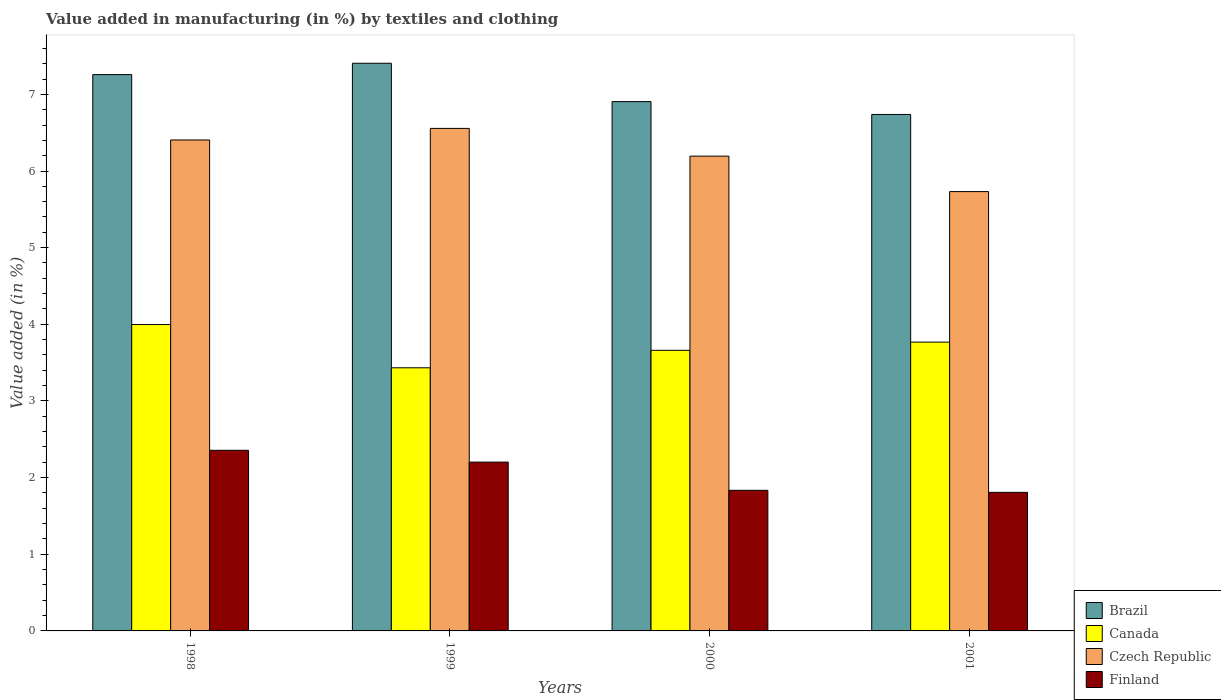How many different coloured bars are there?
Offer a very short reply. 4. How many groups of bars are there?
Your response must be concise. 4. How many bars are there on the 2nd tick from the left?
Offer a terse response. 4. How many bars are there on the 3rd tick from the right?
Offer a terse response. 4. What is the label of the 1st group of bars from the left?
Provide a succinct answer. 1998. What is the percentage of value added in manufacturing by textiles and clothing in Canada in 2000?
Your answer should be very brief. 3.66. Across all years, what is the maximum percentage of value added in manufacturing by textiles and clothing in Finland?
Ensure brevity in your answer.  2.36. Across all years, what is the minimum percentage of value added in manufacturing by textiles and clothing in Brazil?
Your answer should be compact. 6.74. In which year was the percentage of value added in manufacturing by textiles and clothing in Czech Republic maximum?
Keep it short and to the point. 1999. What is the total percentage of value added in manufacturing by textiles and clothing in Canada in the graph?
Make the answer very short. 14.86. What is the difference between the percentage of value added in manufacturing by textiles and clothing in Czech Republic in 1998 and that in 1999?
Give a very brief answer. -0.15. What is the difference between the percentage of value added in manufacturing by textiles and clothing in Czech Republic in 1998 and the percentage of value added in manufacturing by textiles and clothing in Brazil in 2001?
Offer a terse response. -0.33. What is the average percentage of value added in manufacturing by textiles and clothing in Finland per year?
Your answer should be very brief. 2.05. In the year 2001, what is the difference between the percentage of value added in manufacturing by textiles and clothing in Canada and percentage of value added in manufacturing by textiles and clothing in Czech Republic?
Your response must be concise. -1.96. In how many years, is the percentage of value added in manufacturing by textiles and clothing in Finland greater than 0.2 %?
Your answer should be very brief. 4. What is the ratio of the percentage of value added in manufacturing by textiles and clothing in Canada in 1998 to that in 2001?
Make the answer very short. 1.06. What is the difference between the highest and the second highest percentage of value added in manufacturing by textiles and clothing in Canada?
Provide a succinct answer. 0.23. What is the difference between the highest and the lowest percentage of value added in manufacturing by textiles and clothing in Czech Republic?
Provide a succinct answer. 0.82. Is it the case that in every year, the sum of the percentage of value added in manufacturing by textiles and clothing in Canada and percentage of value added in manufacturing by textiles and clothing in Finland is greater than the sum of percentage of value added in manufacturing by textiles and clothing in Brazil and percentage of value added in manufacturing by textiles and clothing in Czech Republic?
Your answer should be very brief. No. What does the 1st bar from the left in 2001 represents?
Offer a very short reply. Brazil. Is it the case that in every year, the sum of the percentage of value added in manufacturing by textiles and clothing in Finland and percentage of value added in manufacturing by textiles and clothing in Canada is greater than the percentage of value added in manufacturing by textiles and clothing in Czech Republic?
Offer a very short reply. No. How many bars are there?
Make the answer very short. 16. Are the values on the major ticks of Y-axis written in scientific E-notation?
Give a very brief answer. No. Does the graph contain any zero values?
Make the answer very short. No. Where does the legend appear in the graph?
Your answer should be compact. Bottom right. How many legend labels are there?
Ensure brevity in your answer.  4. What is the title of the graph?
Provide a short and direct response. Value added in manufacturing (in %) by textiles and clothing. What is the label or title of the Y-axis?
Provide a short and direct response. Value added (in %). What is the Value added (in %) in Brazil in 1998?
Give a very brief answer. 7.26. What is the Value added (in %) in Canada in 1998?
Provide a succinct answer. 4. What is the Value added (in %) of Czech Republic in 1998?
Offer a terse response. 6.4. What is the Value added (in %) in Finland in 1998?
Make the answer very short. 2.36. What is the Value added (in %) in Brazil in 1999?
Offer a very short reply. 7.41. What is the Value added (in %) in Canada in 1999?
Provide a short and direct response. 3.43. What is the Value added (in %) in Czech Republic in 1999?
Your answer should be very brief. 6.56. What is the Value added (in %) of Finland in 1999?
Give a very brief answer. 2.2. What is the Value added (in %) of Brazil in 2000?
Give a very brief answer. 6.91. What is the Value added (in %) of Canada in 2000?
Your response must be concise. 3.66. What is the Value added (in %) of Czech Republic in 2000?
Your response must be concise. 6.19. What is the Value added (in %) in Finland in 2000?
Offer a terse response. 1.83. What is the Value added (in %) in Brazil in 2001?
Your response must be concise. 6.74. What is the Value added (in %) in Canada in 2001?
Provide a short and direct response. 3.77. What is the Value added (in %) in Czech Republic in 2001?
Make the answer very short. 5.73. What is the Value added (in %) in Finland in 2001?
Keep it short and to the point. 1.81. Across all years, what is the maximum Value added (in %) in Brazil?
Your answer should be compact. 7.41. Across all years, what is the maximum Value added (in %) in Canada?
Your response must be concise. 4. Across all years, what is the maximum Value added (in %) of Czech Republic?
Your answer should be compact. 6.56. Across all years, what is the maximum Value added (in %) in Finland?
Give a very brief answer. 2.36. Across all years, what is the minimum Value added (in %) of Brazil?
Your response must be concise. 6.74. Across all years, what is the minimum Value added (in %) in Canada?
Ensure brevity in your answer.  3.43. Across all years, what is the minimum Value added (in %) in Czech Republic?
Provide a short and direct response. 5.73. Across all years, what is the minimum Value added (in %) in Finland?
Keep it short and to the point. 1.81. What is the total Value added (in %) in Brazil in the graph?
Your answer should be very brief. 28.31. What is the total Value added (in %) of Canada in the graph?
Your answer should be compact. 14.86. What is the total Value added (in %) in Czech Republic in the graph?
Keep it short and to the point. 24.89. What is the total Value added (in %) in Finland in the graph?
Your response must be concise. 8.2. What is the difference between the Value added (in %) in Brazil in 1998 and that in 1999?
Ensure brevity in your answer.  -0.15. What is the difference between the Value added (in %) of Canada in 1998 and that in 1999?
Your response must be concise. 0.56. What is the difference between the Value added (in %) of Czech Republic in 1998 and that in 1999?
Make the answer very short. -0.15. What is the difference between the Value added (in %) in Finland in 1998 and that in 1999?
Keep it short and to the point. 0.15. What is the difference between the Value added (in %) of Brazil in 1998 and that in 2000?
Offer a terse response. 0.35. What is the difference between the Value added (in %) in Canada in 1998 and that in 2000?
Your response must be concise. 0.34. What is the difference between the Value added (in %) in Czech Republic in 1998 and that in 2000?
Offer a very short reply. 0.21. What is the difference between the Value added (in %) in Finland in 1998 and that in 2000?
Provide a short and direct response. 0.52. What is the difference between the Value added (in %) in Brazil in 1998 and that in 2001?
Ensure brevity in your answer.  0.52. What is the difference between the Value added (in %) in Canada in 1998 and that in 2001?
Keep it short and to the point. 0.23. What is the difference between the Value added (in %) in Czech Republic in 1998 and that in 2001?
Provide a succinct answer. 0.67. What is the difference between the Value added (in %) of Finland in 1998 and that in 2001?
Offer a very short reply. 0.55. What is the difference between the Value added (in %) in Brazil in 1999 and that in 2000?
Offer a very short reply. 0.5. What is the difference between the Value added (in %) in Canada in 1999 and that in 2000?
Your answer should be compact. -0.23. What is the difference between the Value added (in %) in Czech Republic in 1999 and that in 2000?
Your response must be concise. 0.36. What is the difference between the Value added (in %) of Finland in 1999 and that in 2000?
Your answer should be very brief. 0.37. What is the difference between the Value added (in %) in Brazil in 1999 and that in 2001?
Your response must be concise. 0.67. What is the difference between the Value added (in %) in Canada in 1999 and that in 2001?
Offer a terse response. -0.34. What is the difference between the Value added (in %) of Czech Republic in 1999 and that in 2001?
Offer a terse response. 0.82. What is the difference between the Value added (in %) of Finland in 1999 and that in 2001?
Offer a terse response. 0.39. What is the difference between the Value added (in %) in Brazil in 2000 and that in 2001?
Make the answer very short. 0.17. What is the difference between the Value added (in %) of Canada in 2000 and that in 2001?
Keep it short and to the point. -0.11. What is the difference between the Value added (in %) in Czech Republic in 2000 and that in 2001?
Offer a terse response. 0.46. What is the difference between the Value added (in %) in Finland in 2000 and that in 2001?
Your answer should be very brief. 0.03. What is the difference between the Value added (in %) in Brazil in 1998 and the Value added (in %) in Canada in 1999?
Give a very brief answer. 3.82. What is the difference between the Value added (in %) of Brazil in 1998 and the Value added (in %) of Czech Republic in 1999?
Keep it short and to the point. 0.7. What is the difference between the Value added (in %) in Brazil in 1998 and the Value added (in %) in Finland in 1999?
Your response must be concise. 5.06. What is the difference between the Value added (in %) of Canada in 1998 and the Value added (in %) of Czech Republic in 1999?
Provide a short and direct response. -2.56. What is the difference between the Value added (in %) in Canada in 1998 and the Value added (in %) in Finland in 1999?
Offer a terse response. 1.79. What is the difference between the Value added (in %) of Czech Republic in 1998 and the Value added (in %) of Finland in 1999?
Provide a short and direct response. 4.2. What is the difference between the Value added (in %) of Brazil in 1998 and the Value added (in %) of Canada in 2000?
Give a very brief answer. 3.6. What is the difference between the Value added (in %) in Brazil in 1998 and the Value added (in %) in Czech Republic in 2000?
Give a very brief answer. 1.06. What is the difference between the Value added (in %) of Brazil in 1998 and the Value added (in %) of Finland in 2000?
Keep it short and to the point. 5.42. What is the difference between the Value added (in %) of Canada in 1998 and the Value added (in %) of Czech Republic in 2000?
Offer a very short reply. -2.2. What is the difference between the Value added (in %) in Canada in 1998 and the Value added (in %) in Finland in 2000?
Your answer should be compact. 2.16. What is the difference between the Value added (in %) of Czech Republic in 1998 and the Value added (in %) of Finland in 2000?
Make the answer very short. 4.57. What is the difference between the Value added (in %) of Brazil in 1998 and the Value added (in %) of Canada in 2001?
Provide a short and direct response. 3.49. What is the difference between the Value added (in %) of Brazil in 1998 and the Value added (in %) of Czech Republic in 2001?
Ensure brevity in your answer.  1.53. What is the difference between the Value added (in %) in Brazil in 1998 and the Value added (in %) in Finland in 2001?
Your answer should be very brief. 5.45. What is the difference between the Value added (in %) in Canada in 1998 and the Value added (in %) in Czech Republic in 2001?
Your response must be concise. -1.73. What is the difference between the Value added (in %) in Canada in 1998 and the Value added (in %) in Finland in 2001?
Give a very brief answer. 2.19. What is the difference between the Value added (in %) in Czech Republic in 1998 and the Value added (in %) in Finland in 2001?
Keep it short and to the point. 4.6. What is the difference between the Value added (in %) of Brazil in 1999 and the Value added (in %) of Canada in 2000?
Provide a succinct answer. 3.74. What is the difference between the Value added (in %) of Brazil in 1999 and the Value added (in %) of Czech Republic in 2000?
Your response must be concise. 1.21. What is the difference between the Value added (in %) in Brazil in 1999 and the Value added (in %) in Finland in 2000?
Offer a terse response. 5.57. What is the difference between the Value added (in %) of Canada in 1999 and the Value added (in %) of Czech Republic in 2000?
Your answer should be compact. -2.76. What is the difference between the Value added (in %) in Canada in 1999 and the Value added (in %) in Finland in 2000?
Ensure brevity in your answer.  1.6. What is the difference between the Value added (in %) in Czech Republic in 1999 and the Value added (in %) in Finland in 2000?
Offer a very short reply. 4.72. What is the difference between the Value added (in %) of Brazil in 1999 and the Value added (in %) of Canada in 2001?
Provide a succinct answer. 3.64. What is the difference between the Value added (in %) of Brazil in 1999 and the Value added (in %) of Czech Republic in 2001?
Your answer should be compact. 1.67. What is the difference between the Value added (in %) in Brazil in 1999 and the Value added (in %) in Finland in 2001?
Your response must be concise. 5.6. What is the difference between the Value added (in %) in Canada in 1999 and the Value added (in %) in Czech Republic in 2001?
Keep it short and to the point. -2.3. What is the difference between the Value added (in %) in Canada in 1999 and the Value added (in %) in Finland in 2001?
Your answer should be very brief. 1.62. What is the difference between the Value added (in %) of Czech Republic in 1999 and the Value added (in %) of Finland in 2001?
Keep it short and to the point. 4.75. What is the difference between the Value added (in %) of Brazil in 2000 and the Value added (in %) of Canada in 2001?
Offer a very short reply. 3.14. What is the difference between the Value added (in %) in Brazil in 2000 and the Value added (in %) in Czech Republic in 2001?
Provide a short and direct response. 1.17. What is the difference between the Value added (in %) of Brazil in 2000 and the Value added (in %) of Finland in 2001?
Your answer should be compact. 5.1. What is the difference between the Value added (in %) in Canada in 2000 and the Value added (in %) in Czech Republic in 2001?
Your answer should be very brief. -2.07. What is the difference between the Value added (in %) in Canada in 2000 and the Value added (in %) in Finland in 2001?
Offer a very short reply. 1.85. What is the difference between the Value added (in %) of Czech Republic in 2000 and the Value added (in %) of Finland in 2001?
Provide a short and direct response. 4.39. What is the average Value added (in %) in Brazil per year?
Make the answer very short. 7.08. What is the average Value added (in %) of Canada per year?
Give a very brief answer. 3.71. What is the average Value added (in %) of Czech Republic per year?
Offer a very short reply. 6.22. What is the average Value added (in %) in Finland per year?
Offer a terse response. 2.05. In the year 1998, what is the difference between the Value added (in %) in Brazil and Value added (in %) in Canada?
Your response must be concise. 3.26. In the year 1998, what is the difference between the Value added (in %) in Brazil and Value added (in %) in Czech Republic?
Make the answer very short. 0.85. In the year 1998, what is the difference between the Value added (in %) of Brazil and Value added (in %) of Finland?
Your response must be concise. 4.9. In the year 1998, what is the difference between the Value added (in %) of Canada and Value added (in %) of Czech Republic?
Your answer should be compact. -2.41. In the year 1998, what is the difference between the Value added (in %) of Canada and Value added (in %) of Finland?
Your answer should be very brief. 1.64. In the year 1998, what is the difference between the Value added (in %) of Czech Republic and Value added (in %) of Finland?
Your response must be concise. 4.05. In the year 1999, what is the difference between the Value added (in %) of Brazil and Value added (in %) of Canada?
Your answer should be compact. 3.97. In the year 1999, what is the difference between the Value added (in %) in Brazil and Value added (in %) in Czech Republic?
Your response must be concise. 0.85. In the year 1999, what is the difference between the Value added (in %) in Brazil and Value added (in %) in Finland?
Make the answer very short. 5.2. In the year 1999, what is the difference between the Value added (in %) of Canada and Value added (in %) of Czech Republic?
Keep it short and to the point. -3.12. In the year 1999, what is the difference between the Value added (in %) of Canada and Value added (in %) of Finland?
Offer a very short reply. 1.23. In the year 1999, what is the difference between the Value added (in %) in Czech Republic and Value added (in %) in Finland?
Offer a very short reply. 4.35. In the year 2000, what is the difference between the Value added (in %) in Brazil and Value added (in %) in Canada?
Offer a very short reply. 3.24. In the year 2000, what is the difference between the Value added (in %) of Brazil and Value added (in %) of Czech Republic?
Keep it short and to the point. 0.71. In the year 2000, what is the difference between the Value added (in %) in Brazil and Value added (in %) in Finland?
Provide a succinct answer. 5.07. In the year 2000, what is the difference between the Value added (in %) of Canada and Value added (in %) of Czech Republic?
Your response must be concise. -2.53. In the year 2000, what is the difference between the Value added (in %) in Canada and Value added (in %) in Finland?
Your response must be concise. 1.83. In the year 2000, what is the difference between the Value added (in %) of Czech Republic and Value added (in %) of Finland?
Make the answer very short. 4.36. In the year 2001, what is the difference between the Value added (in %) of Brazil and Value added (in %) of Canada?
Your response must be concise. 2.97. In the year 2001, what is the difference between the Value added (in %) in Brazil and Value added (in %) in Finland?
Offer a terse response. 4.93. In the year 2001, what is the difference between the Value added (in %) of Canada and Value added (in %) of Czech Republic?
Your response must be concise. -1.96. In the year 2001, what is the difference between the Value added (in %) of Canada and Value added (in %) of Finland?
Ensure brevity in your answer.  1.96. In the year 2001, what is the difference between the Value added (in %) of Czech Republic and Value added (in %) of Finland?
Make the answer very short. 3.92. What is the ratio of the Value added (in %) in Canada in 1998 to that in 1999?
Your answer should be very brief. 1.16. What is the ratio of the Value added (in %) in Czech Republic in 1998 to that in 1999?
Your answer should be compact. 0.98. What is the ratio of the Value added (in %) in Finland in 1998 to that in 1999?
Your answer should be very brief. 1.07. What is the ratio of the Value added (in %) in Brazil in 1998 to that in 2000?
Provide a succinct answer. 1.05. What is the ratio of the Value added (in %) in Canada in 1998 to that in 2000?
Give a very brief answer. 1.09. What is the ratio of the Value added (in %) of Czech Republic in 1998 to that in 2000?
Your response must be concise. 1.03. What is the ratio of the Value added (in %) in Finland in 1998 to that in 2000?
Provide a succinct answer. 1.28. What is the ratio of the Value added (in %) of Brazil in 1998 to that in 2001?
Offer a terse response. 1.08. What is the ratio of the Value added (in %) in Canada in 1998 to that in 2001?
Keep it short and to the point. 1.06. What is the ratio of the Value added (in %) of Czech Republic in 1998 to that in 2001?
Provide a short and direct response. 1.12. What is the ratio of the Value added (in %) of Finland in 1998 to that in 2001?
Offer a very short reply. 1.3. What is the ratio of the Value added (in %) in Brazil in 1999 to that in 2000?
Give a very brief answer. 1.07. What is the ratio of the Value added (in %) in Canada in 1999 to that in 2000?
Offer a very short reply. 0.94. What is the ratio of the Value added (in %) of Czech Republic in 1999 to that in 2000?
Give a very brief answer. 1.06. What is the ratio of the Value added (in %) in Finland in 1999 to that in 2000?
Your answer should be compact. 1.2. What is the ratio of the Value added (in %) in Brazil in 1999 to that in 2001?
Your answer should be very brief. 1.1. What is the ratio of the Value added (in %) of Canada in 1999 to that in 2001?
Give a very brief answer. 0.91. What is the ratio of the Value added (in %) in Czech Republic in 1999 to that in 2001?
Make the answer very short. 1.14. What is the ratio of the Value added (in %) of Finland in 1999 to that in 2001?
Give a very brief answer. 1.22. What is the ratio of the Value added (in %) in Brazil in 2000 to that in 2001?
Keep it short and to the point. 1.02. What is the ratio of the Value added (in %) in Canada in 2000 to that in 2001?
Your answer should be very brief. 0.97. What is the ratio of the Value added (in %) in Czech Republic in 2000 to that in 2001?
Your response must be concise. 1.08. What is the ratio of the Value added (in %) in Finland in 2000 to that in 2001?
Your answer should be very brief. 1.01. What is the difference between the highest and the second highest Value added (in %) in Brazil?
Provide a short and direct response. 0.15. What is the difference between the highest and the second highest Value added (in %) of Canada?
Provide a short and direct response. 0.23. What is the difference between the highest and the second highest Value added (in %) in Czech Republic?
Offer a terse response. 0.15. What is the difference between the highest and the second highest Value added (in %) of Finland?
Provide a short and direct response. 0.15. What is the difference between the highest and the lowest Value added (in %) in Brazil?
Ensure brevity in your answer.  0.67. What is the difference between the highest and the lowest Value added (in %) of Canada?
Make the answer very short. 0.56. What is the difference between the highest and the lowest Value added (in %) in Czech Republic?
Your response must be concise. 0.82. What is the difference between the highest and the lowest Value added (in %) of Finland?
Provide a succinct answer. 0.55. 